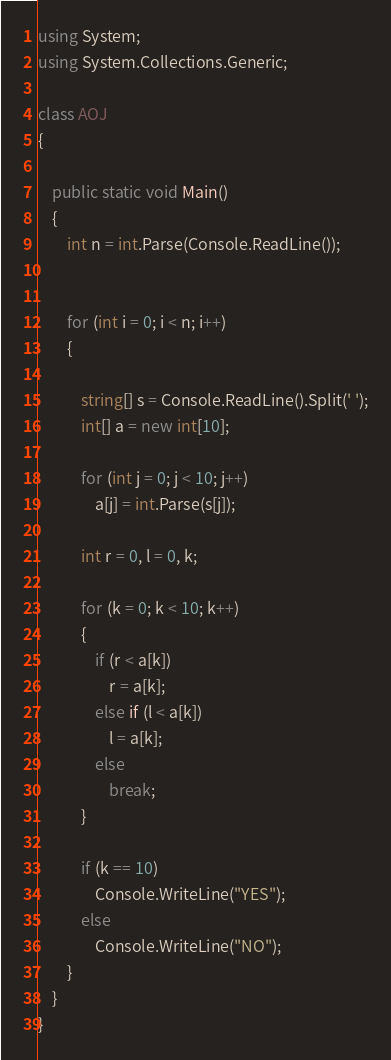Convert code to text. <code><loc_0><loc_0><loc_500><loc_500><_C#_>using System;
using System.Collections.Generic;

class AOJ
{

    public static void Main()
    {
        int n = int.Parse(Console.ReadLine());


        for (int i = 0; i < n; i++)
        {

            string[] s = Console.ReadLine().Split(' ');
            int[] a = new int[10];

            for (int j = 0; j < 10; j++)
                a[j] = int.Parse(s[j]);

            int r = 0, l = 0, k;

            for (k = 0; k < 10; k++)
            {
                if (r < a[k])
                    r = a[k];
                else if (l < a[k])
                    l = a[k];
                else
                    break;
            }

            if (k == 10)
                Console.WriteLine("YES");
            else
                Console.WriteLine("NO");
        }
    }
}</code> 